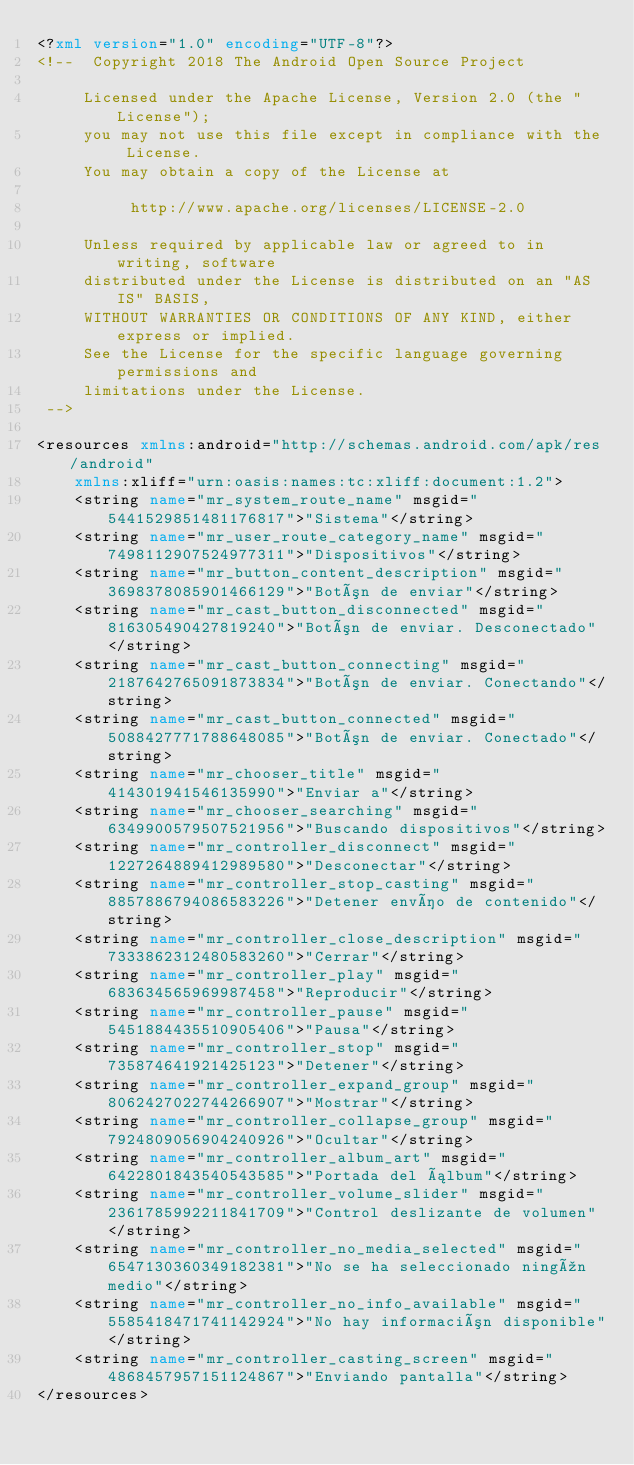<code> <loc_0><loc_0><loc_500><loc_500><_XML_><?xml version="1.0" encoding="UTF-8"?>
<!--  Copyright 2018 The Android Open Source Project

     Licensed under the Apache License, Version 2.0 (the "License");
     you may not use this file except in compliance with the License.
     You may obtain a copy of the License at

          http://www.apache.org/licenses/LICENSE-2.0

     Unless required by applicable law or agreed to in writing, software
     distributed under the License is distributed on an "AS IS" BASIS,
     WITHOUT WARRANTIES OR CONDITIONS OF ANY KIND, either express or implied.
     See the License for the specific language governing permissions and
     limitations under the License.
 -->

<resources xmlns:android="http://schemas.android.com/apk/res/android"
    xmlns:xliff="urn:oasis:names:tc:xliff:document:1.2">
    <string name="mr_system_route_name" msgid="5441529851481176817">"Sistema"</string>
    <string name="mr_user_route_category_name" msgid="7498112907524977311">"Dispositivos"</string>
    <string name="mr_button_content_description" msgid="3698378085901466129">"Botón de enviar"</string>
    <string name="mr_cast_button_disconnected" msgid="816305490427819240">"Botón de enviar. Desconectado"</string>
    <string name="mr_cast_button_connecting" msgid="2187642765091873834">"Botón de enviar. Conectando"</string>
    <string name="mr_cast_button_connected" msgid="5088427771788648085">"Botón de enviar. Conectado"</string>
    <string name="mr_chooser_title" msgid="414301941546135990">"Enviar a"</string>
    <string name="mr_chooser_searching" msgid="6349900579507521956">"Buscando dispositivos"</string>
    <string name="mr_controller_disconnect" msgid="1227264889412989580">"Desconectar"</string>
    <string name="mr_controller_stop_casting" msgid="8857886794086583226">"Detener envío de contenido"</string>
    <string name="mr_controller_close_description" msgid="7333862312480583260">"Cerrar"</string>
    <string name="mr_controller_play" msgid="683634565969987458">"Reproducir"</string>
    <string name="mr_controller_pause" msgid="5451884435510905406">"Pausa"</string>
    <string name="mr_controller_stop" msgid="735874641921425123">"Detener"</string>
    <string name="mr_controller_expand_group" msgid="8062427022744266907">"Mostrar"</string>
    <string name="mr_controller_collapse_group" msgid="7924809056904240926">"Ocultar"</string>
    <string name="mr_controller_album_art" msgid="6422801843540543585">"Portada del álbum"</string>
    <string name="mr_controller_volume_slider" msgid="2361785992211841709">"Control deslizante de volumen"</string>
    <string name="mr_controller_no_media_selected" msgid="6547130360349182381">"No se ha seleccionado ningún medio"</string>
    <string name="mr_controller_no_info_available" msgid="5585418471741142924">"No hay información disponible"</string>
    <string name="mr_controller_casting_screen" msgid="4868457957151124867">"Enviando pantalla"</string>
</resources>
</code> 